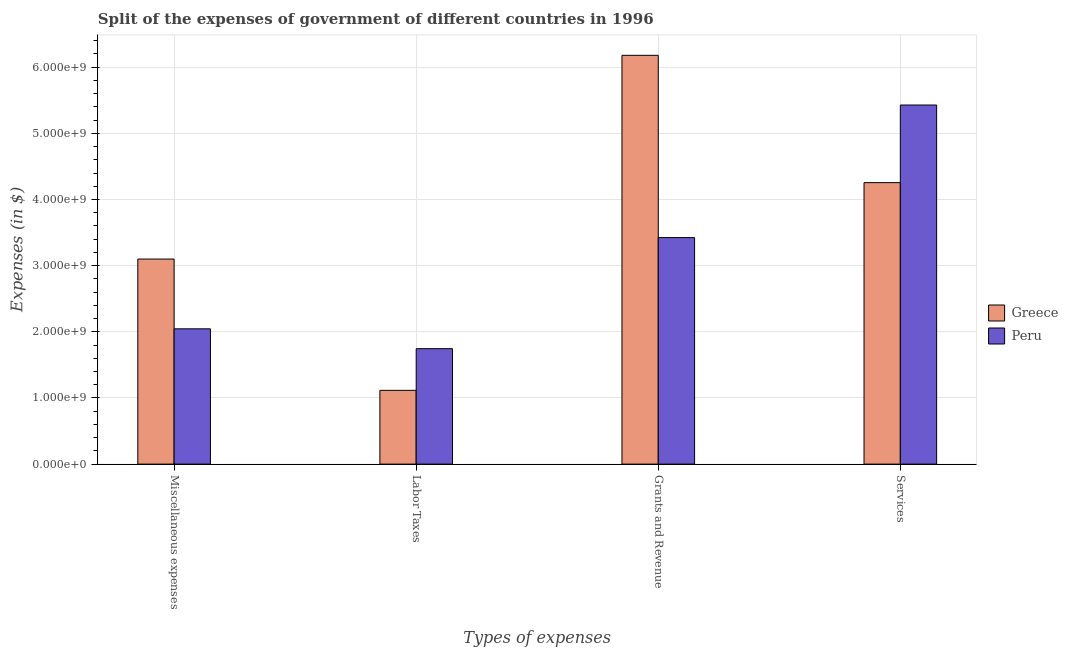Are the number of bars on each tick of the X-axis equal?
Keep it short and to the point. Yes. How many bars are there on the 4th tick from the right?
Make the answer very short. 2. What is the label of the 2nd group of bars from the left?
Your response must be concise. Labor Taxes. What is the amount spent on labor taxes in Greece?
Offer a very short reply. 1.12e+09. Across all countries, what is the maximum amount spent on miscellaneous expenses?
Offer a very short reply. 3.10e+09. Across all countries, what is the minimum amount spent on miscellaneous expenses?
Ensure brevity in your answer.  2.05e+09. In which country was the amount spent on grants and revenue minimum?
Your answer should be very brief. Peru. What is the total amount spent on services in the graph?
Offer a terse response. 9.68e+09. What is the difference between the amount spent on labor taxes in Peru and that in Greece?
Give a very brief answer. 6.30e+08. What is the difference between the amount spent on grants and revenue in Peru and the amount spent on services in Greece?
Ensure brevity in your answer.  -8.30e+08. What is the average amount spent on services per country?
Give a very brief answer. 4.84e+09. What is the difference between the amount spent on miscellaneous expenses and amount spent on labor taxes in Peru?
Give a very brief answer. 3.00e+08. What is the ratio of the amount spent on labor taxes in Peru to that in Greece?
Your answer should be very brief. 1.57. Is the amount spent on labor taxes in Greece less than that in Peru?
Your response must be concise. Yes. Is the difference between the amount spent on services in Peru and Greece greater than the difference between the amount spent on labor taxes in Peru and Greece?
Provide a short and direct response. Yes. What is the difference between the highest and the second highest amount spent on labor taxes?
Provide a succinct answer. 6.30e+08. What is the difference between the highest and the lowest amount spent on miscellaneous expenses?
Your answer should be compact. 1.05e+09. In how many countries, is the amount spent on labor taxes greater than the average amount spent on labor taxes taken over all countries?
Your answer should be compact. 1. What does the 1st bar from the right in Labor Taxes represents?
Make the answer very short. Peru. Is it the case that in every country, the sum of the amount spent on miscellaneous expenses and amount spent on labor taxes is greater than the amount spent on grants and revenue?
Provide a succinct answer. No. Are all the bars in the graph horizontal?
Ensure brevity in your answer.  No. Does the graph contain grids?
Give a very brief answer. Yes. Where does the legend appear in the graph?
Give a very brief answer. Center right. How are the legend labels stacked?
Provide a short and direct response. Vertical. What is the title of the graph?
Give a very brief answer. Split of the expenses of government of different countries in 1996. Does "Hong Kong" appear as one of the legend labels in the graph?
Your answer should be compact. No. What is the label or title of the X-axis?
Your answer should be very brief. Types of expenses. What is the label or title of the Y-axis?
Offer a very short reply. Expenses (in $). What is the Expenses (in $) in Greece in Miscellaneous expenses?
Keep it short and to the point. 3.10e+09. What is the Expenses (in $) in Peru in Miscellaneous expenses?
Give a very brief answer. 2.05e+09. What is the Expenses (in $) in Greece in Labor Taxes?
Offer a very short reply. 1.12e+09. What is the Expenses (in $) of Peru in Labor Taxes?
Give a very brief answer. 1.75e+09. What is the Expenses (in $) of Greece in Grants and Revenue?
Give a very brief answer. 6.18e+09. What is the Expenses (in $) of Peru in Grants and Revenue?
Provide a succinct answer. 3.42e+09. What is the Expenses (in $) of Greece in Services?
Provide a succinct answer. 4.26e+09. What is the Expenses (in $) of Peru in Services?
Ensure brevity in your answer.  5.43e+09. Across all Types of expenses, what is the maximum Expenses (in $) of Greece?
Your answer should be compact. 6.18e+09. Across all Types of expenses, what is the maximum Expenses (in $) in Peru?
Offer a very short reply. 5.43e+09. Across all Types of expenses, what is the minimum Expenses (in $) of Greece?
Your answer should be compact. 1.12e+09. Across all Types of expenses, what is the minimum Expenses (in $) of Peru?
Ensure brevity in your answer.  1.75e+09. What is the total Expenses (in $) of Greece in the graph?
Offer a very short reply. 1.46e+1. What is the total Expenses (in $) in Peru in the graph?
Give a very brief answer. 1.26e+1. What is the difference between the Expenses (in $) of Greece in Miscellaneous expenses and that in Labor Taxes?
Your answer should be very brief. 1.98e+09. What is the difference between the Expenses (in $) of Peru in Miscellaneous expenses and that in Labor Taxes?
Provide a short and direct response. 3.00e+08. What is the difference between the Expenses (in $) in Greece in Miscellaneous expenses and that in Grants and Revenue?
Make the answer very short. -3.08e+09. What is the difference between the Expenses (in $) of Peru in Miscellaneous expenses and that in Grants and Revenue?
Your response must be concise. -1.38e+09. What is the difference between the Expenses (in $) in Greece in Miscellaneous expenses and that in Services?
Offer a very short reply. -1.16e+09. What is the difference between the Expenses (in $) of Peru in Miscellaneous expenses and that in Services?
Provide a short and direct response. -3.38e+09. What is the difference between the Expenses (in $) in Greece in Labor Taxes and that in Grants and Revenue?
Keep it short and to the point. -5.06e+09. What is the difference between the Expenses (in $) in Peru in Labor Taxes and that in Grants and Revenue?
Ensure brevity in your answer.  -1.68e+09. What is the difference between the Expenses (in $) in Greece in Labor Taxes and that in Services?
Ensure brevity in your answer.  -3.14e+09. What is the difference between the Expenses (in $) of Peru in Labor Taxes and that in Services?
Provide a succinct answer. -3.68e+09. What is the difference between the Expenses (in $) in Greece in Grants and Revenue and that in Services?
Offer a terse response. 1.92e+09. What is the difference between the Expenses (in $) in Peru in Grants and Revenue and that in Services?
Your answer should be compact. -2.00e+09. What is the difference between the Expenses (in $) of Greece in Miscellaneous expenses and the Expenses (in $) of Peru in Labor Taxes?
Make the answer very short. 1.35e+09. What is the difference between the Expenses (in $) in Greece in Miscellaneous expenses and the Expenses (in $) in Peru in Grants and Revenue?
Offer a terse response. -3.24e+08. What is the difference between the Expenses (in $) of Greece in Miscellaneous expenses and the Expenses (in $) of Peru in Services?
Your answer should be very brief. -2.33e+09. What is the difference between the Expenses (in $) in Greece in Labor Taxes and the Expenses (in $) in Peru in Grants and Revenue?
Offer a very short reply. -2.31e+09. What is the difference between the Expenses (in $) of Greece in Labor Taxes and the Expenses (in $) of Peru in Services?
Offer a terse response. -4.31e+09. What is the difference between the Expenses (in $) in Greece in Grants and Revenue and the Expenses (in $) in Peru in Services?
Provide a succinct answer. 7.51e+08. What is the average Expenses (in $) in Greece per Types of expenses?
Make the answer very short. 3.66e+09. What is the average Expenses (in $) of Peru per Types of expenses?
Ensure brevity in your answer.  3.16e+09. What is the difference between the Expenses (in $) in Greece and Expenses (in $) in Peru in Miscellaneous expenses?
Your response must be concise. 1.05e+09. What is the difference between the Expenses (in $) in Greece and Expenses (in $) in Peru in Labor Taxes?
Your response must be concise. -6.30e+08. What is the difference between the Expenses (in $) of Greece and Expenses (in $) of Peru in Grants and Revenue?
Your answer should be very brief. 2.76e+09. What is the difference between the Expenses (in $) in Greece and Expenses (in $) in Peru in Services?
Offer a very short reply. -1.17e+09. What is the ratio of the Expenses (in $) in Greece in Miscellaneous expenses to that in Labor Taxes?
Give a very brief answer. 2.78. What is the ratio of the Expenses (in $) of Peru in Miscellaneous expenses to that in Labor Taxes?
Your answer should be compact. 1.17. What is the ratio of the Expenses (in $) of Greece in Miscellaneous expenses to that in Grants and Revenue?
Offer a very short reply. 0.5. What is the ratio of the Expenses (in $) in Peru in Miscellaneous expenses to that in Grants and Revenue?
Provide a succinct answer. 0.6. What is the ratio of the Expenses (in $) in Greece in Miscellaneous expenses to that in Services?
Keep it short and to the point. 0.73. What is the ratio of the Expenses (in $) in Peru in Miscellaneous expenses to that in Services?
Ensure brevity in your answer.  0.38. What is the ratio of the Expenses (in $) in Greece in Labor Taxes to that in Grants and Revenue?
Make the answer very short. 0.18. What is the ratio of the Expenses (in $) of Peru in Labor Taxes to that in Grants and Revenue?
Give a very brief answer. 0.51. What is the ratio of the Expenses (in $) in Greece in Labor Taxes to that in Services?
Your response must be concise. 0.26. What is the ratio of the Expenses (in $) of Peru in Labor Taxes to that in Services?
Your answer should be compact. 0.32. What is the ratio of the Expenses (in $) of Greece in Grants and Revenue to that in Services?
Give a very brief answer. 1.45. What is the ratio of the Expenses (in $) in Peru in Grants and Revenue to that in Services?
Offer a very short reply. 0.63. What is the difference between the highest and the second highest Expenses (in $) of Greece?
Offer a very short reply. 1.92e+09. What is the difference between the highest and the second highest Expenses (in $) in Peru?
Your response must be concise. 2.00e+09. What is the difference between the highest and the lowest Expenses (in $) in Greece?
Provide a short and direct response. 5.06e+09. What is the difference between the highest and the lowest Expenses (in $) of Peru?
Offer a terse response. 3.68e+09. 